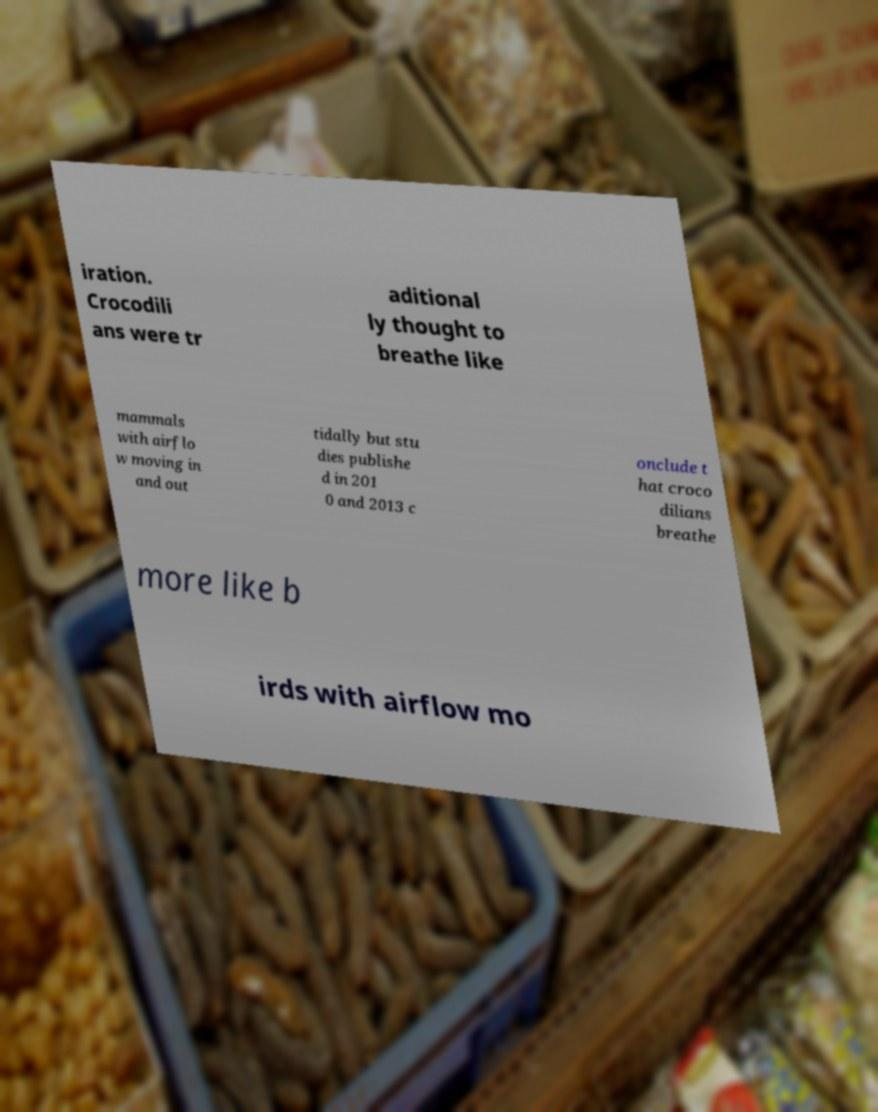There's text embedded in this image that I need extracted. Can you transcribe it verbatim? iration. Crocodili ans were tr aditional ly thought to breathe like mammals with airflo w moving in and out tidally but stu dies publishe d in 201 0 and 2013 c onclude t hat croco dilians breathe more like b irds with airflow mo 